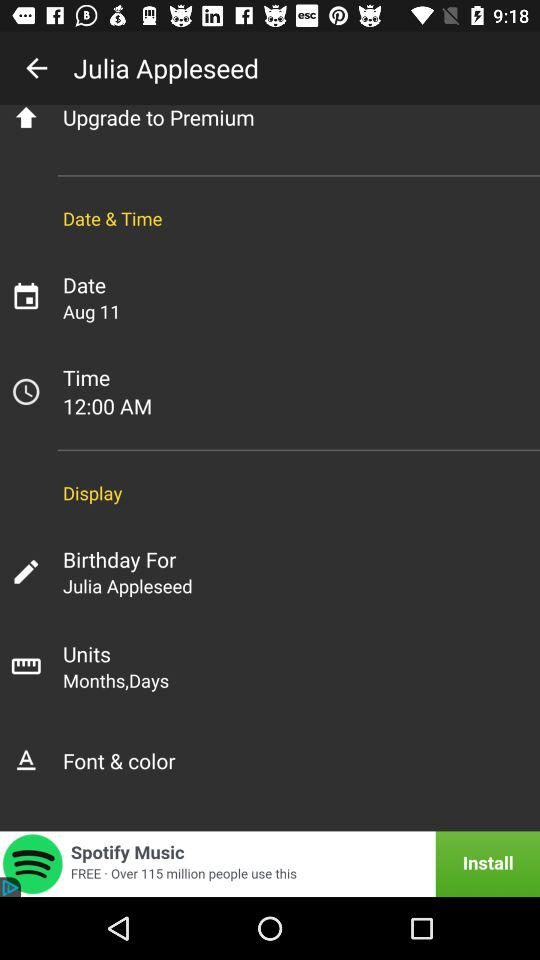What is the given time? The given time is 12:00 AM. 